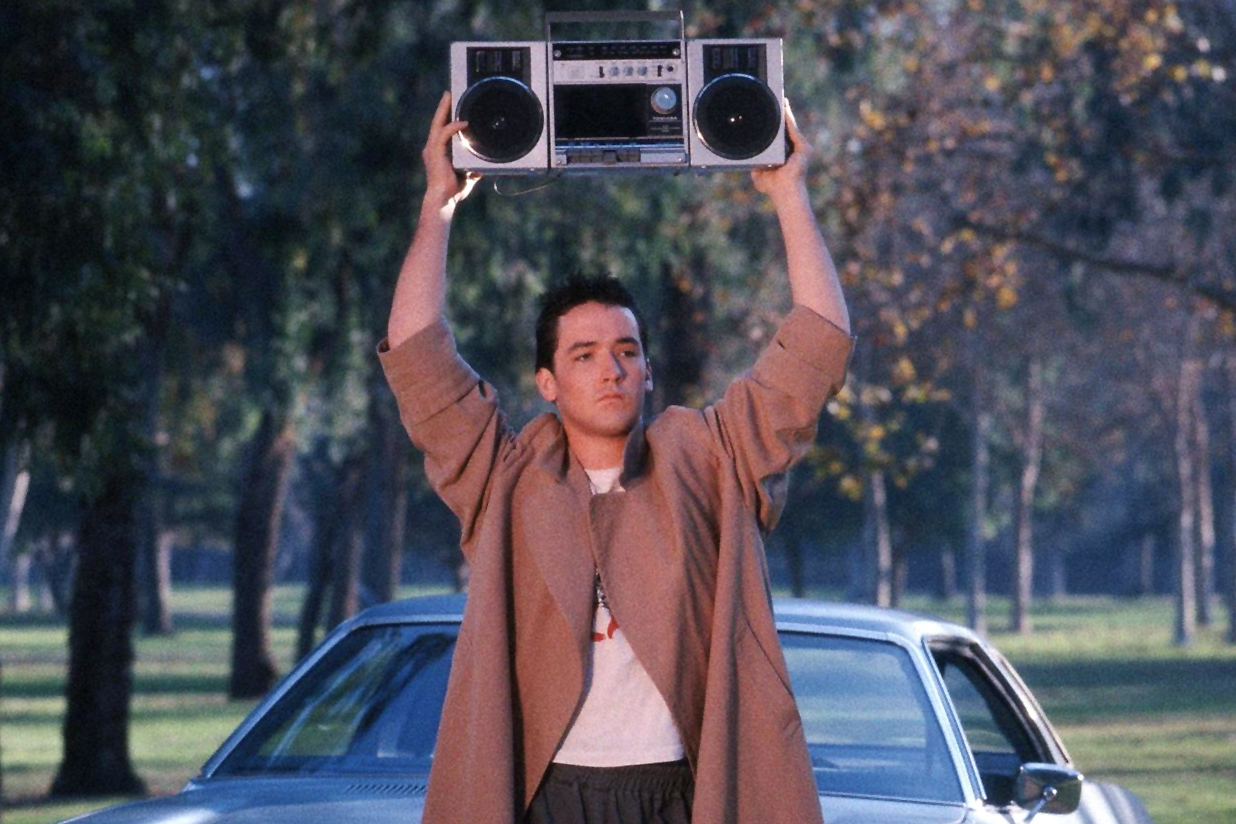Explain the significance of the setting in this scene. The setting of this scene plays a crucial role in amplifying the emotional impact of the moment. Lloyd Dobler stands in what appears to be a quiet suburban area, with a car parked behind him and trees providing a natural backdrop. This serene and somewhat isolated environment contrasts sharply with the intense emotion and boldness of his gesture. The tranquility of the surroundings emphasizes the singular focus and determination of Lloyd as he expresses his love. The choice of setting underscores the theme of reaching out and making grand gestures despite the mundanity of everyday life, highlighting the beauty and power of romantic resolve in an ordinary world. 